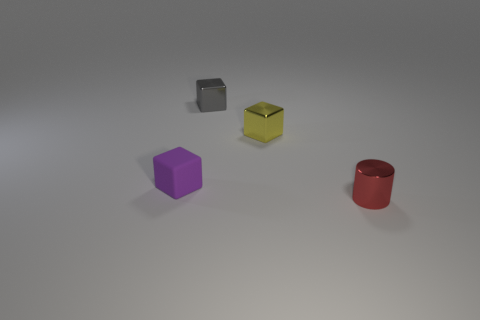Subtract all yellow shiny cubes. How many cubes are left? 2 Add 2 large matte objects. How many objects exist? 6 Subtract all green cubes. Subtract all cyan spheres. How many cubes are left? 3 Subtract all cylinders. How many objects are left? 3 Subtract all purple metal things. Subtract all small cylinders. How many objects are left? 3 Add 2 small cubes. How many small cubes are left? 5 Add 3 yellow metal objects. How many yellow metal objects exist? 4 Subtract 0 brown blocks. How many objects are left? 4 